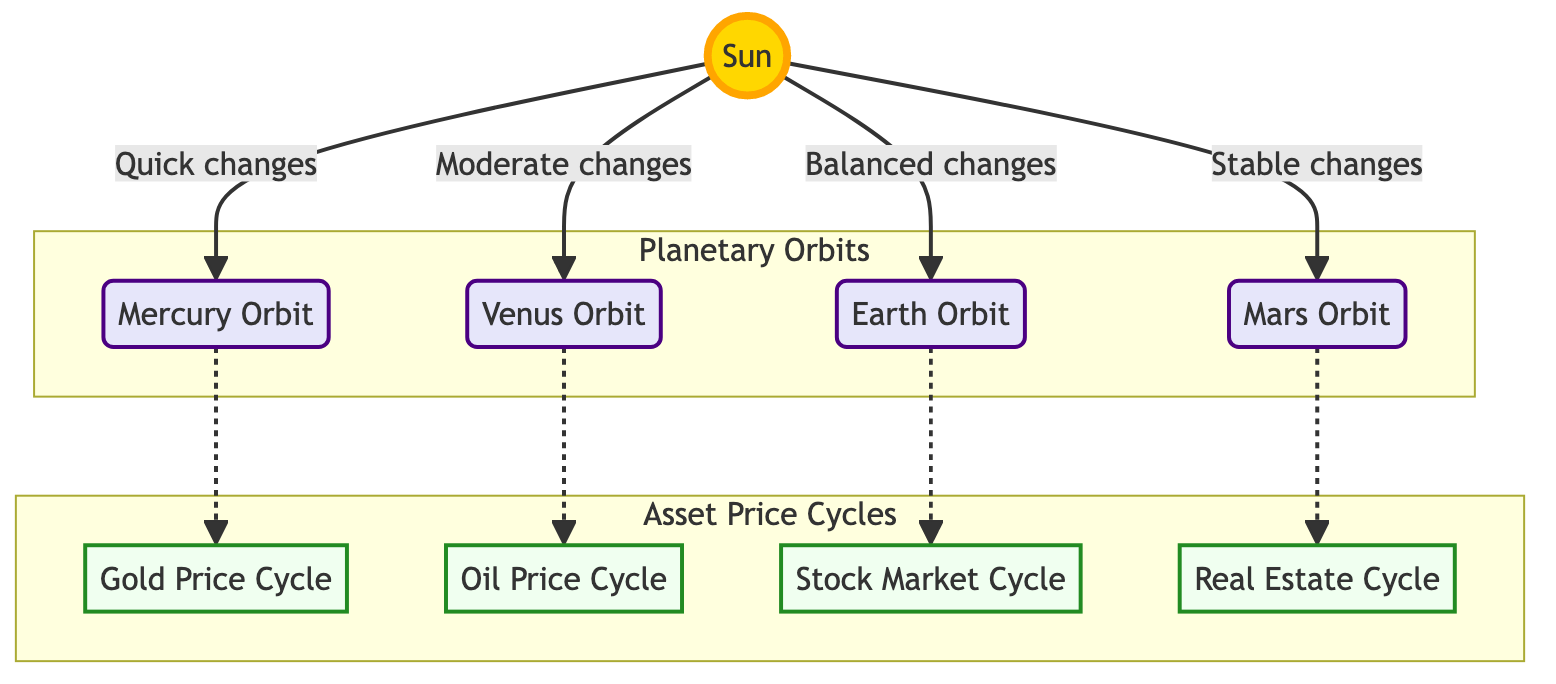What is the color representing the Sun? The Sun node in the diagram uses the color #FFD700 for its fill, which corresponds to a shade of gold.
Answer: Gold How many planetary orbits are shown in the diagram? The diagram features four planetary orbits: Mercury, Venus, Earth, and Mars. Counting these, we find that there are exactly four orbits depicted.
Answer: Four Which asset price cycle is associated with the Earth Orbit? The Earth Orbit is connected to the Stock Market Cycle within the diagram. This is indicated by the direct link between those two nodes.
Answer: Stock Market Cycle What type of changes does the Mars Orbit experience? According to the diagram, the relationship between the Sun and Mars Orbit is labeled as "Stable changes." This indicates the nature of changes experienced by the Mars Orbit.
Answer: Stable changes Which two asset price cycles are indirectly connected to the Mercury Orbit? The diagram shows that the Mercury Orbit leads to the Gold Price Cycle as well as to the Oil Price Cycle via dashed arrows, indicating an indirect connection.
Answer: Gold Price Cycle and Oil Price Cycle What type of connection exists between Venus Orbit and Oil Price Cycle? The connection is depicted as a dotted line (dashed arrow), which is a visual representation of an indirect relationship in the diagram.
Answer: Dotted line How many total cycles are represented in the Asset Price Cycles section? The Asset Price Cycles section includes four cycles: Gold Price Cycle, Oil Price Cycle, Stock Market Cycle, and Real Estate Cycle, which can be counted directly from the diagram nodes.
Answer: Four Which orbit has the quickest changes according to the diagram? The diagram indicates that Mercury Orbit experiences "Quick changes" as a description of its relationship with the Sun, highlighting the nature of its orbit changes.
Answer: Mercury Orbit What is the visual style of the orbits compared to the cycles? The orbits are styled with a fill color of light lavender (#E6E6FA) and a stroke of indigo, while the asset cycles are filled with a very light green (#F0FFF0) and use a forest green stroke. This provides a distinct visual differentiation between the two groups.
Answer: Different colors and styles 